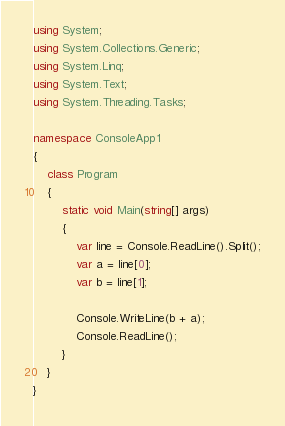<code> <loc_0><loc_0><loc_500><loc_500><_C#_>using System;
using System.Collections.Generic;
using System.Linq;
using System.Text;
using System.Threading.Tasks;

namespace ConsoleApp1
{
    class Program
    {
        static void Main(string[] args)
        {
            var line = Console.ReadLine().Split();
            var a = line[0];
            var b = line[1];

            Console.WriteLine(b + a);
            Console.ReadLine();
        }
    }
}</code> 